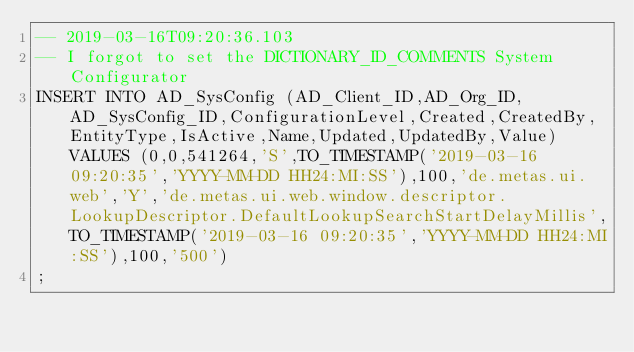Convert code to text. <code><loc_0><loc_0><loc_500><loc_500><_SQL_>-- 2019-03-16T09:20:36.103
-- I forgot to set the DICTIONARY_ID_COMMENTS System Configurator
INSERT INTO AD_SysConfig (AD_Client_ID,AD_Org_ID,AD_SysConfig_ID,ConfigurationLevel,Created,CreatedBy,EntityType,IsActive,Name,Updated,UpdatedBy,Value) VALUES (0,0,541264,'S',TO_TIMESTAMP('2019-03-16 09:20:35','YYYY-MM-DD HH24:MI:SS'),100,'de.metas.ui.web','Y','de.metas.ui.web.window.descriptor.LookupDescriptor.DefaultLookupSearchStartDelayMillis',TO_TIMESTAMP('2019-03-16 09:20:35','YYYY-MM-DD HH24:MI:SS'),100,'500')
;

</code> 